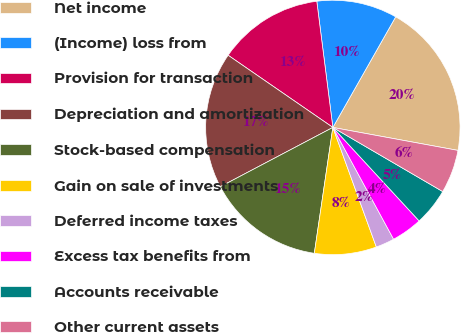Convert chart. <chart><loc_0><loc_0><loc_500><loc_500><pie_chart><fcel>Net income<fcel>(Income) loss from<fcel>Provision for transaction<fcel>Depreciation and amortization<fcel>Stock-based compensation<fcel>Gain on sale of investments<fcel>Deferred income taxes<fcel>Excess tax benefits from<fcel>Accounts receivable<fcel>Other current assets<nl><fcel>19.67%<fcel>10.24%<fcel>13.38%<fcel>17.32%<fcel>14.96%<fcel>7.88%<fcel>2.37%<fcel>3.94%<fcel>4.73%<fcel>5.52%<nl></chart> 